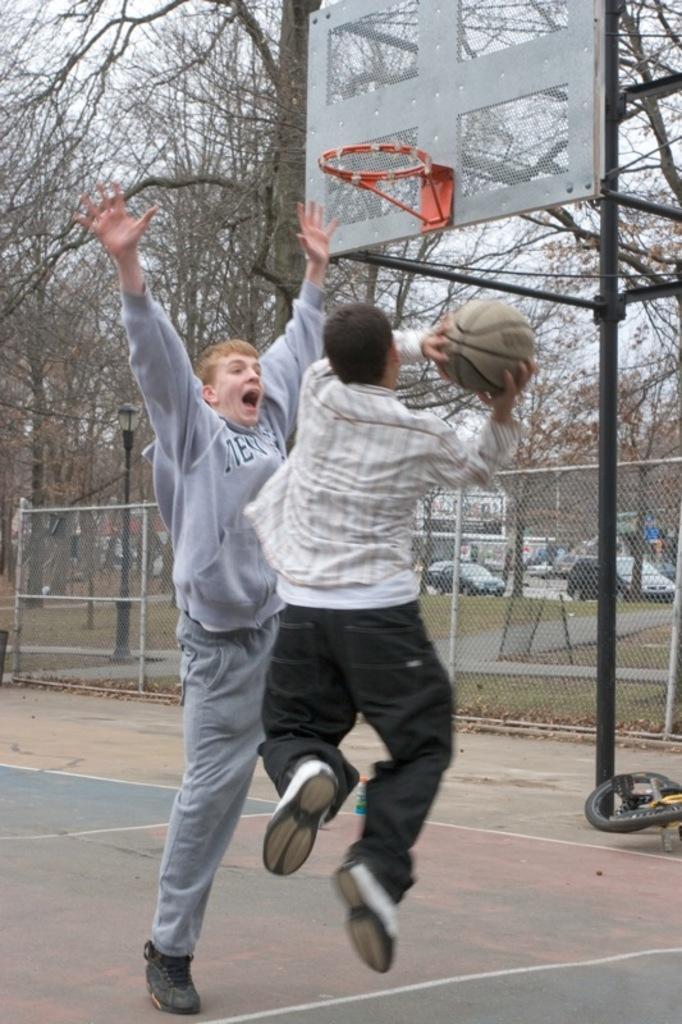Could you give a brief overview of what you see in this image? In this picture there are two boys in the center of the image, they are playing basketball and there are trees and cars in the background area of the image. 